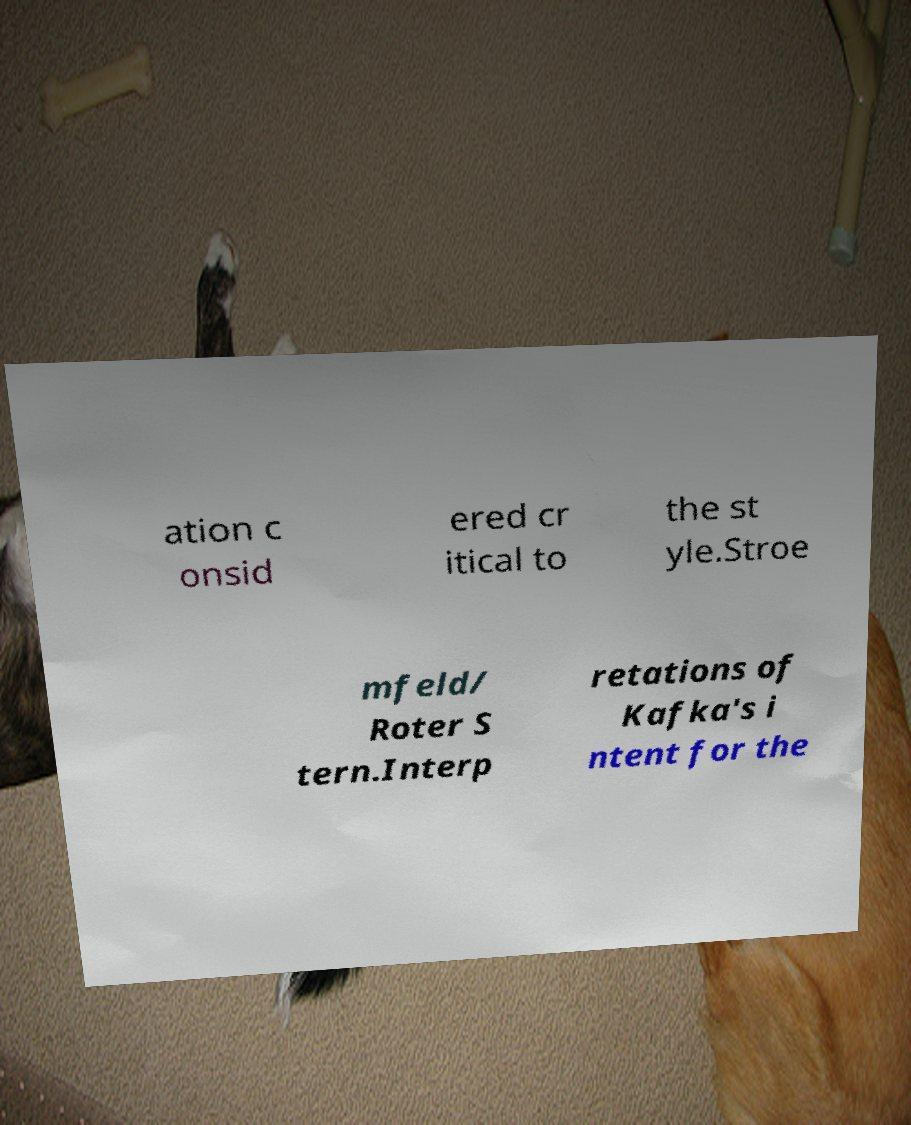Can you read and provide the text displayed in the image?This photo seems to have some interesting text. Can you extract and type it out for me? ation c onsid ered cr itical to the st yle.Stroe mfeld/ Roter S tern.Interp retations of Kafka's i ntent for the 